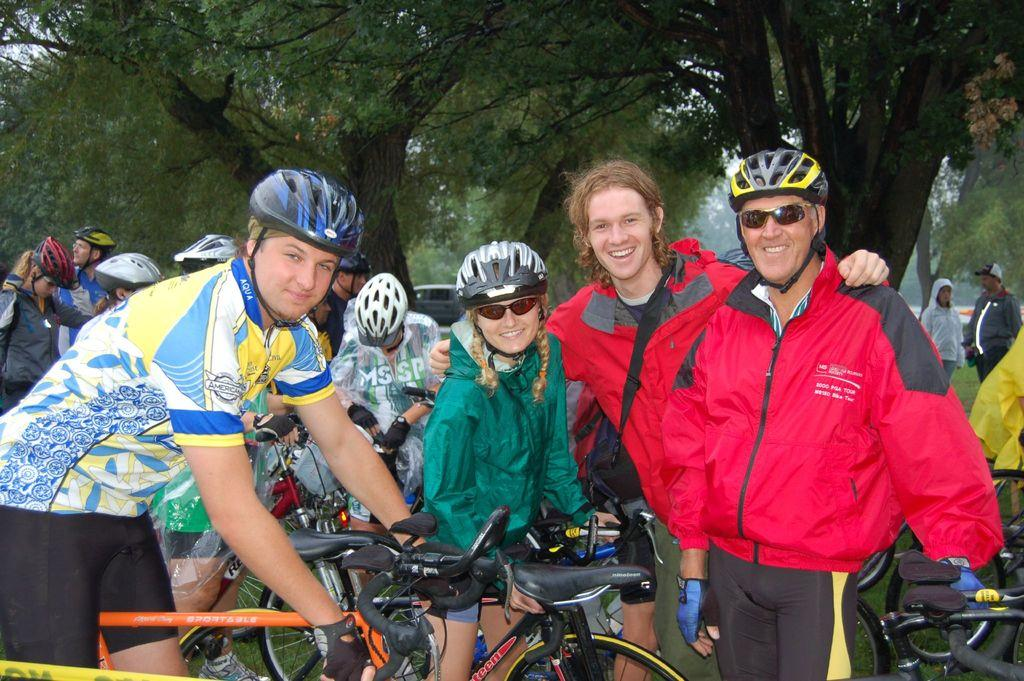What are the people in the image doing? There are people standing in the image. What objects are some of the people holding? Some people are holding bicycles in the image. What can be seen in the background of the image? There are trees and the sky visible in the background of the image. Where is the kitty attempting to find its home in the image? There is no kitty present in the image, and therefore no such attempt can be observed. 